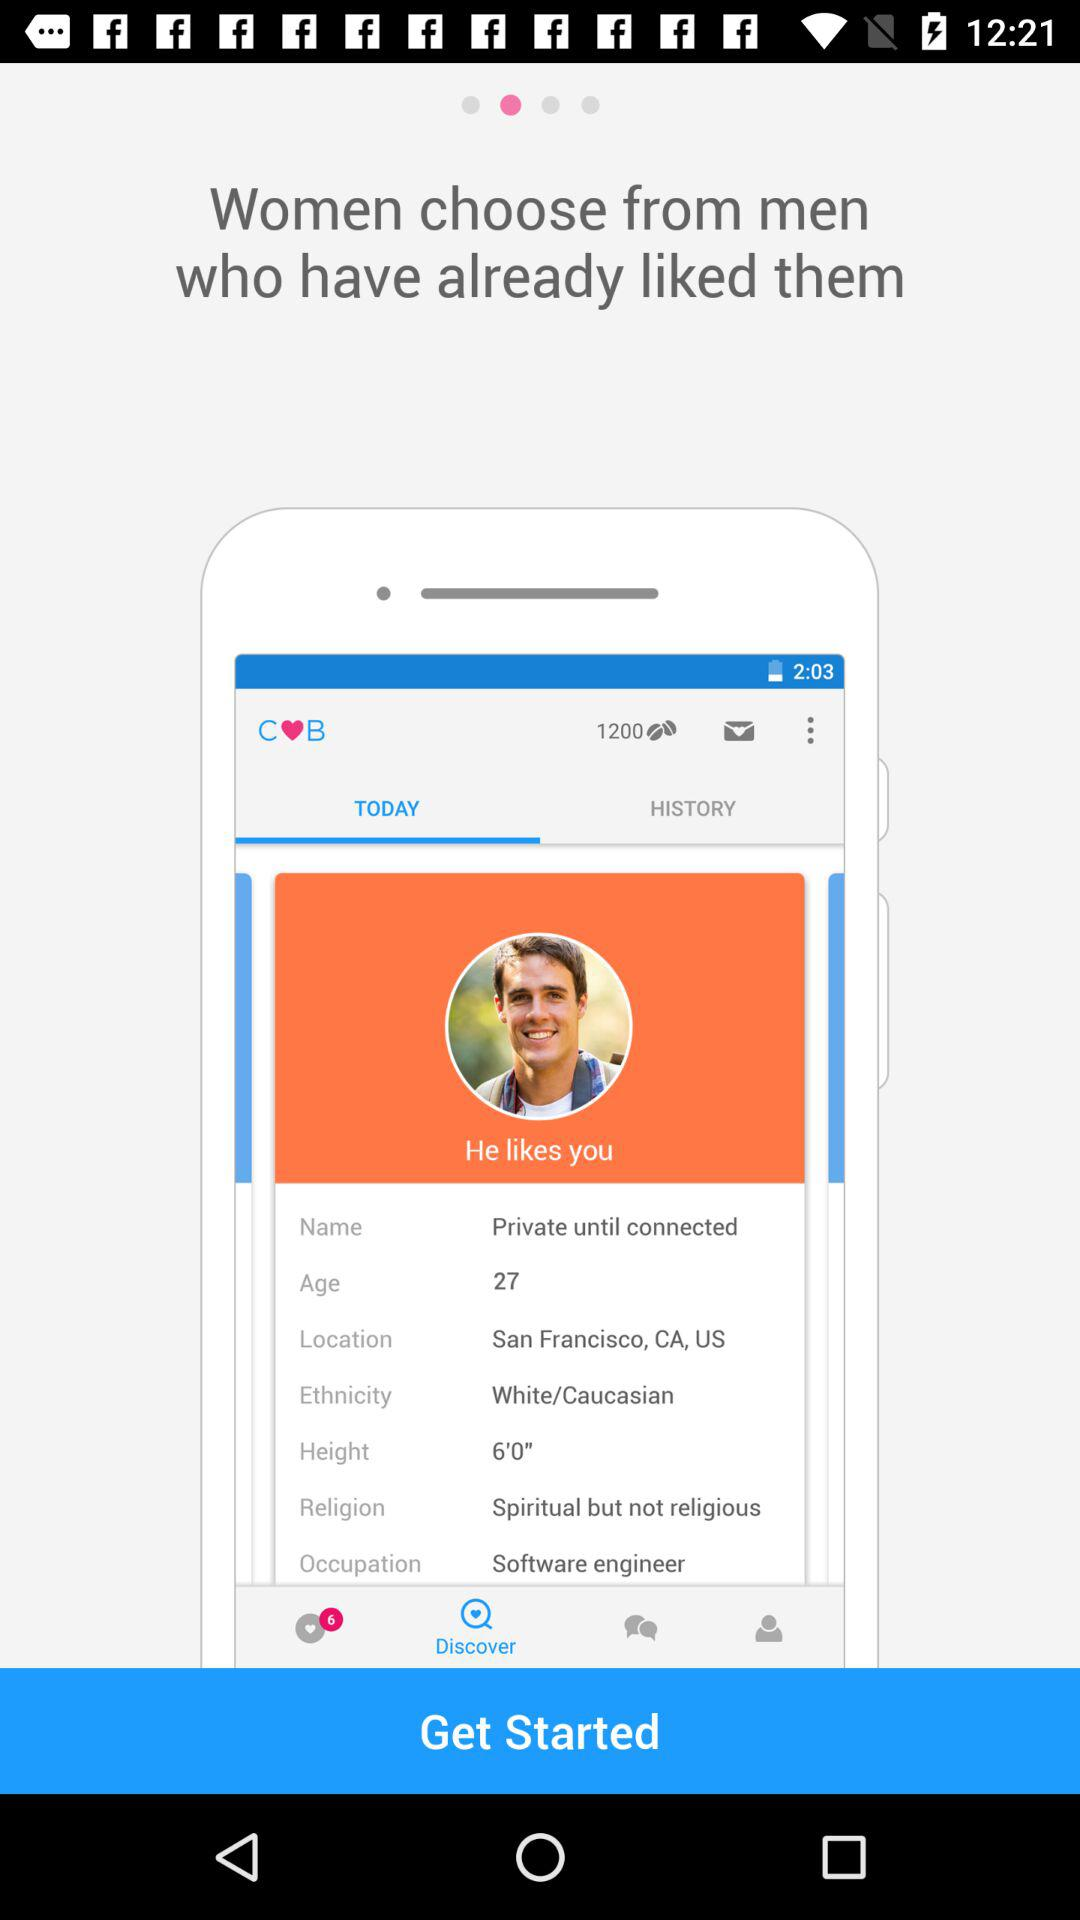What is the religious status of the person? The religious status of the person is "Spiritual but not religious". 